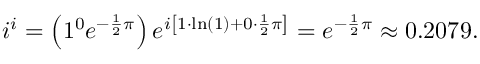Convert formula to latex. <formula><loc_0><loc_0><loc_500><loc_500>i ^ { i } = \left ( 1 ^ { 0 } e ^ { - { \frac { 1 } { 2 } } \pi } \right ) e ^ { i \left [ 1 \cdot \ln ( 1 ) + 0 \cdot { \frac { 1 } { 2 } } \pi \right ] } = e ^ { - { \frac { 1 } { 2 } } \pi } \approx 0 . 2 0 7 9 .</formula> 